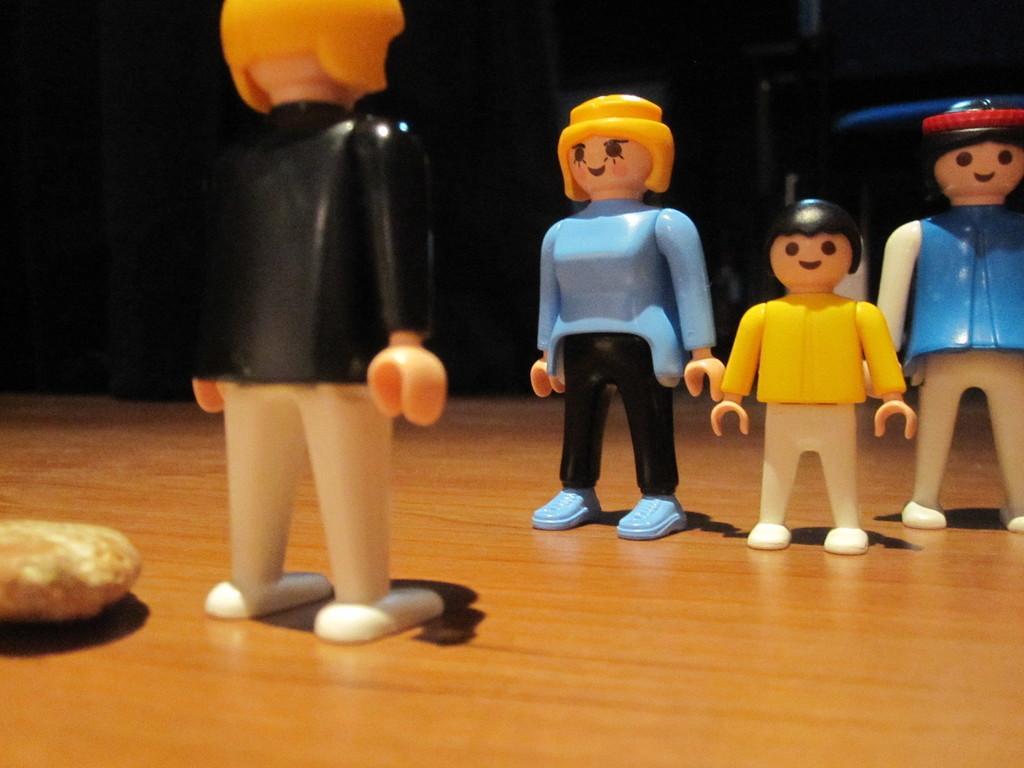How would you summarize this image in a sentence or two? In this image we can see toys on the wooden surface. 